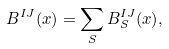Convert formula to latex. <formula><loc_0><loc_0><loc_500><loc_500>B ^ { I J } ( x ) = \sum _ { S } B ^ { I J } _ { S } ( x ) ,</formula> 